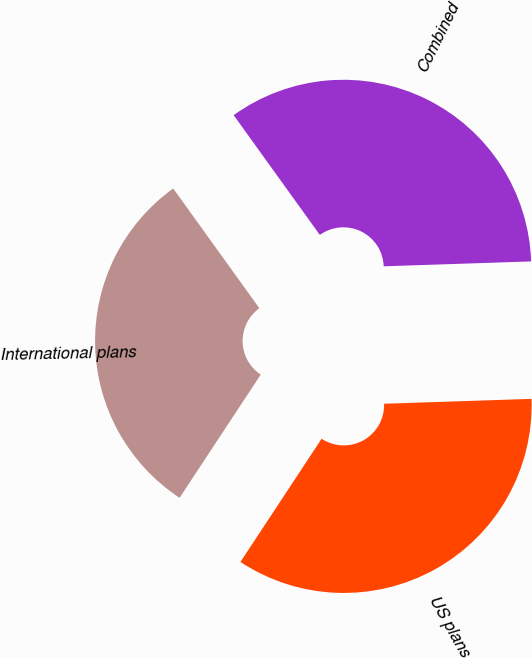<chart> <loc_0><loc_0><loc_500><loc_500><pie_chart><fcel>US plans<fcel>International plans<fcel>Combined<nl><fcel>34.8%<fcel>30.8%<fcel>34.4%<nl></chart> 